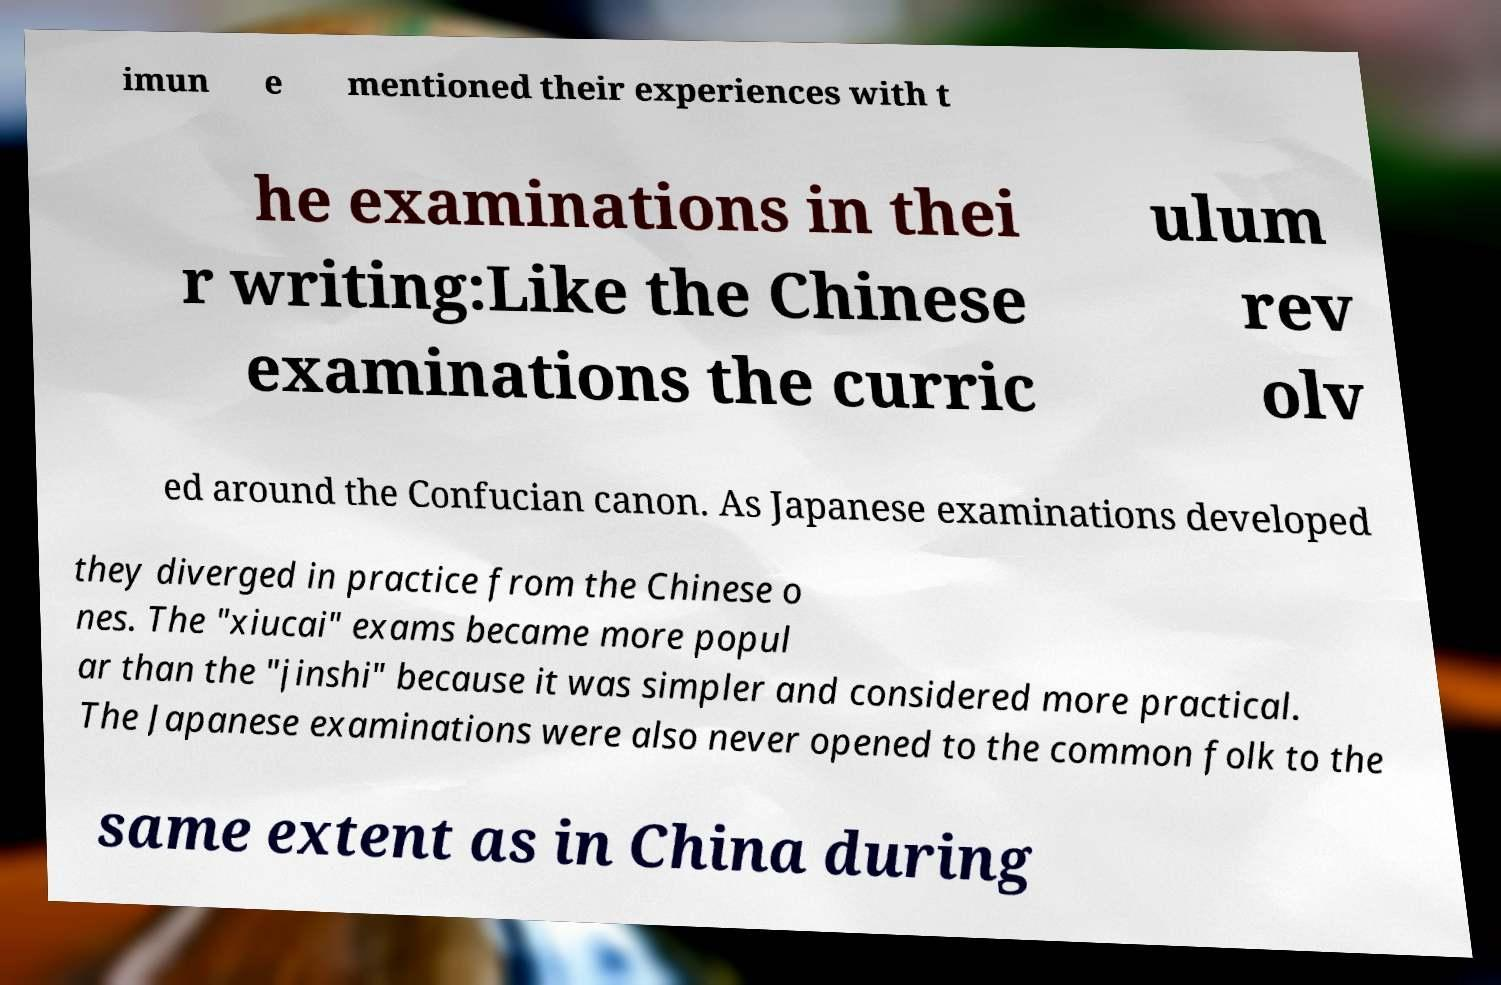Please identify and transcribe the text found in this image. imun e mentioned their experiences with t he examinations in thei r writing:Like the Chinese examinations the curric ulum rev olv ed around the Confucian canon. As Japanese examinations developed they diverged in practice from the Chinese o nes. The "xiucai" exams became more popul ar than the "jinshi" because it was simpler and considered more practical. The Japanese examinations were also never opened to the common folk to the same extent as in China during 